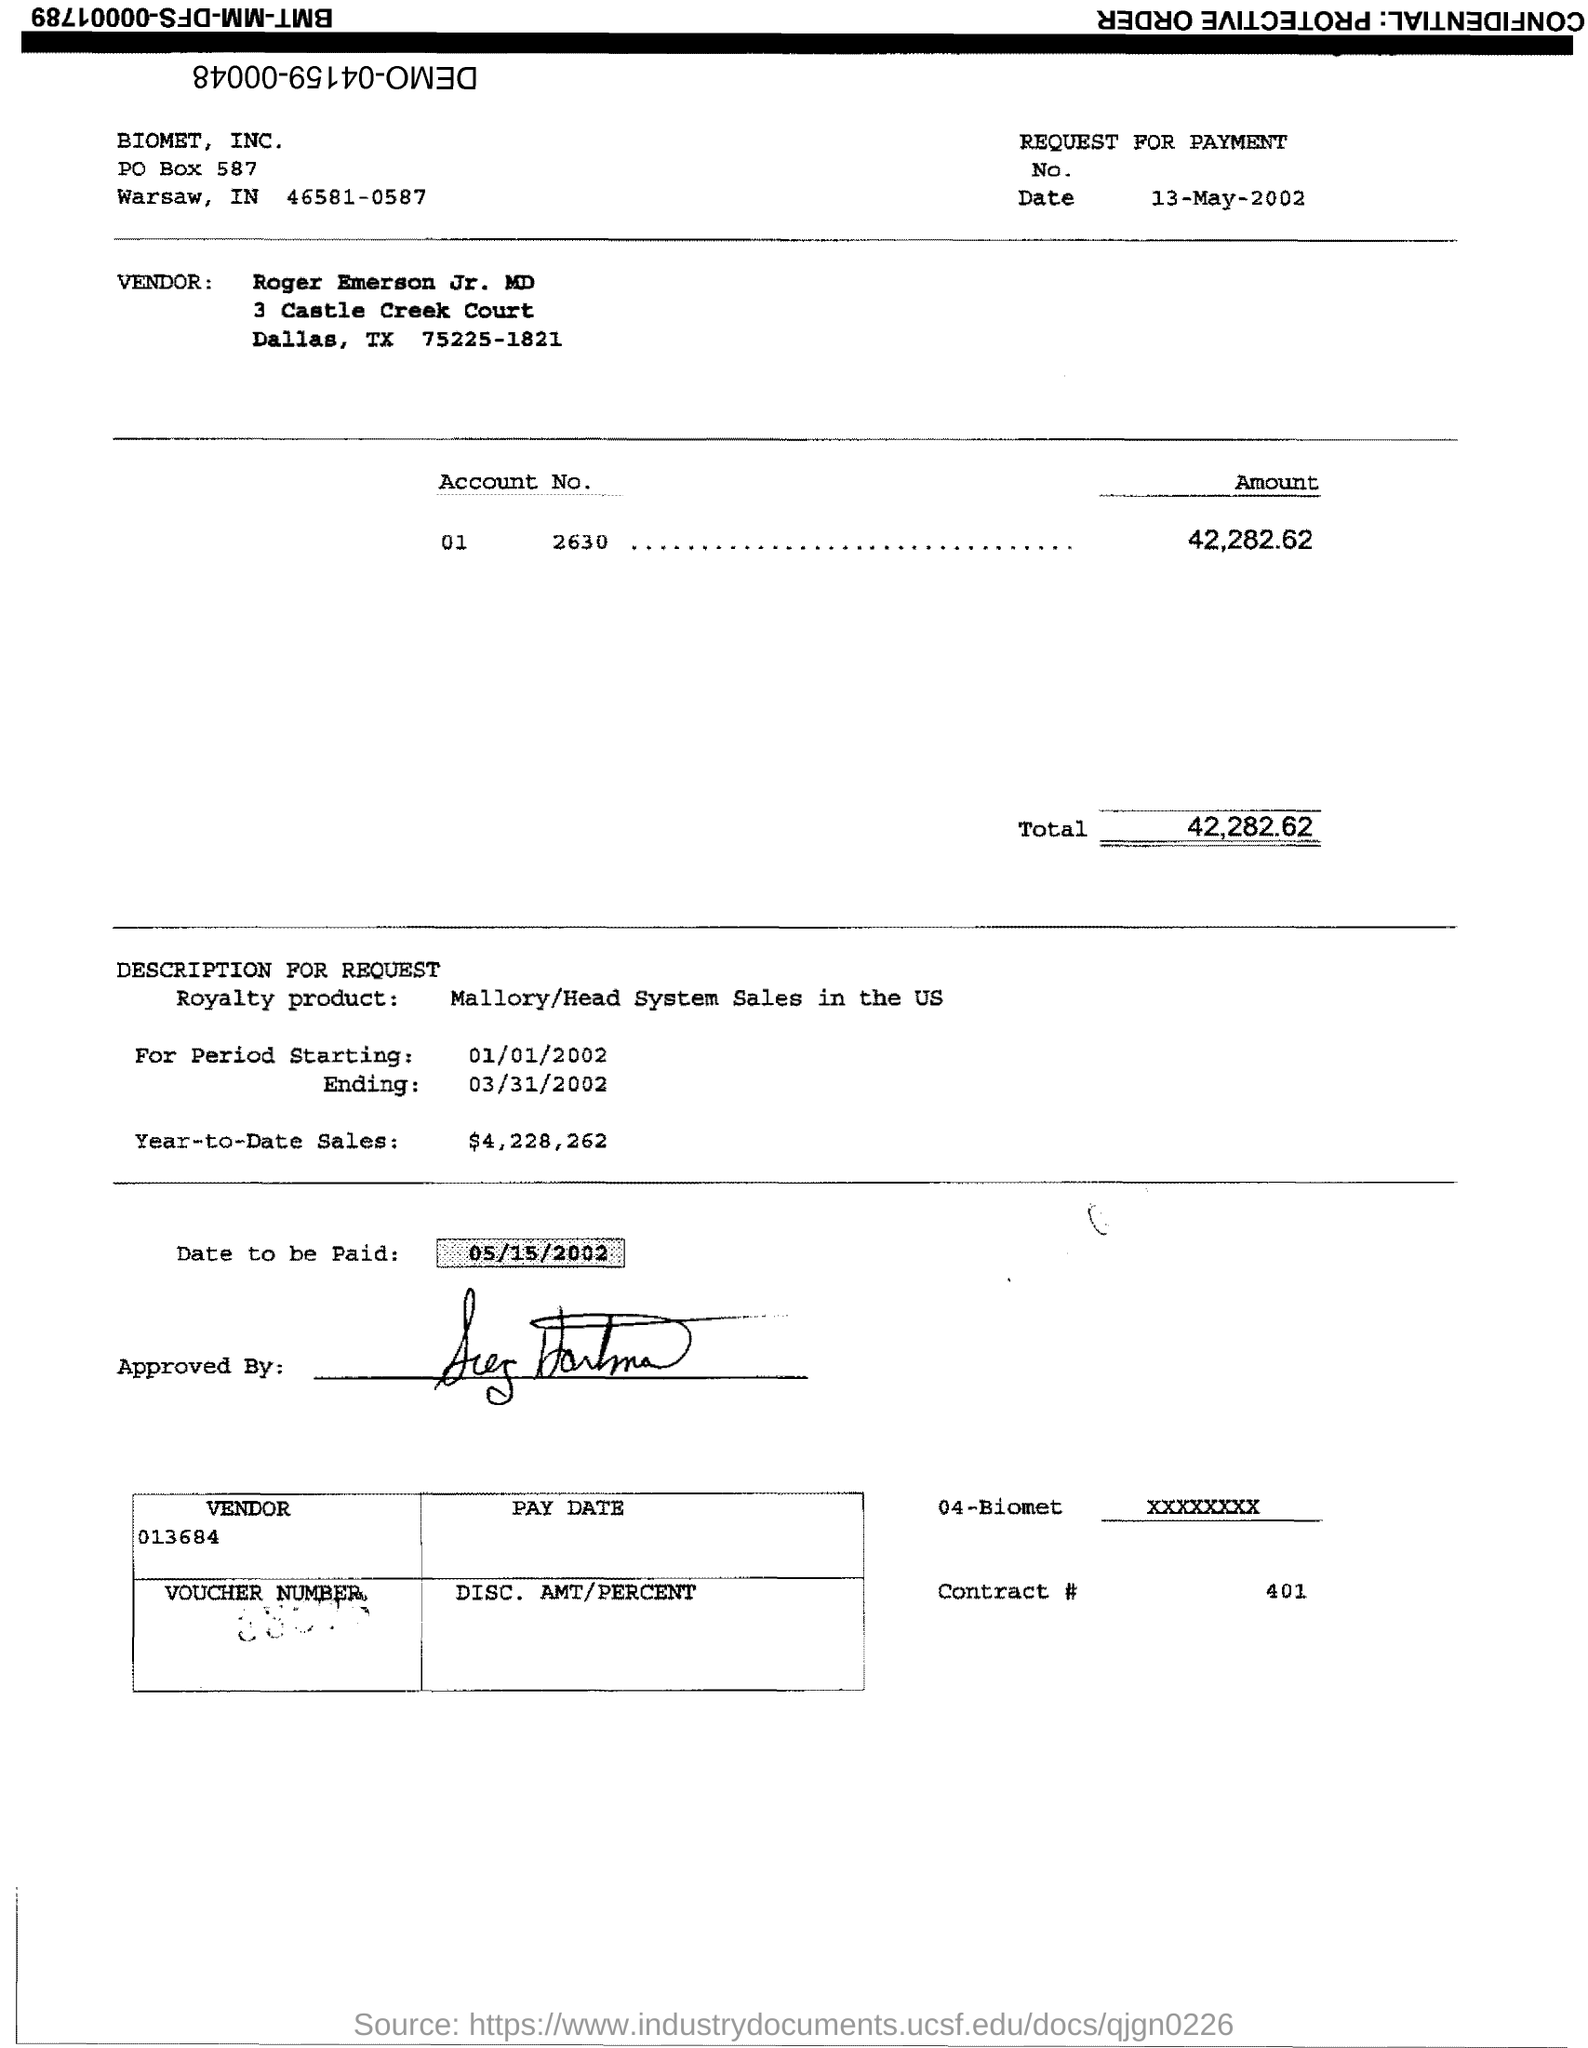What is the Total? The total amount requested for payment as shown on the document is $42,282.62. 